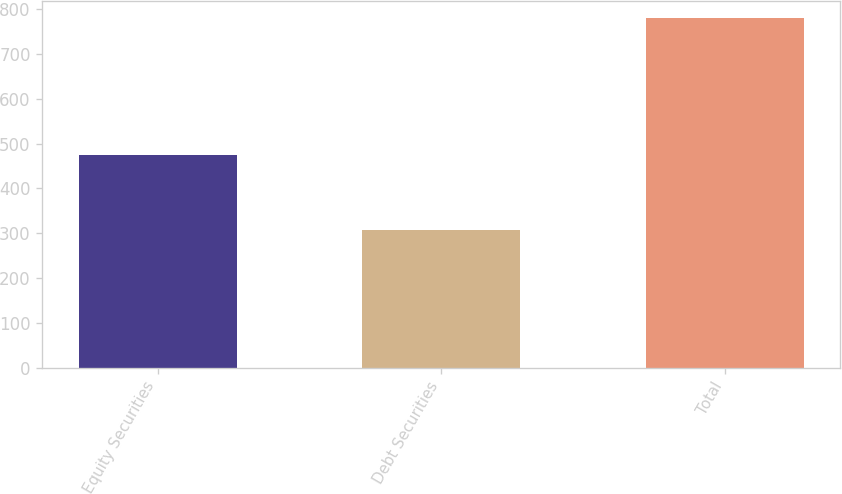Convert chart. <chart><loc_0><loc_0><loc_500><loc_500><bar_chart><fcel>Equity Securities<fcel>Debt Securities<fcel>Total<nl><fcel>473.9<fcel>306.6<fcel>780.5<nl></chart> 